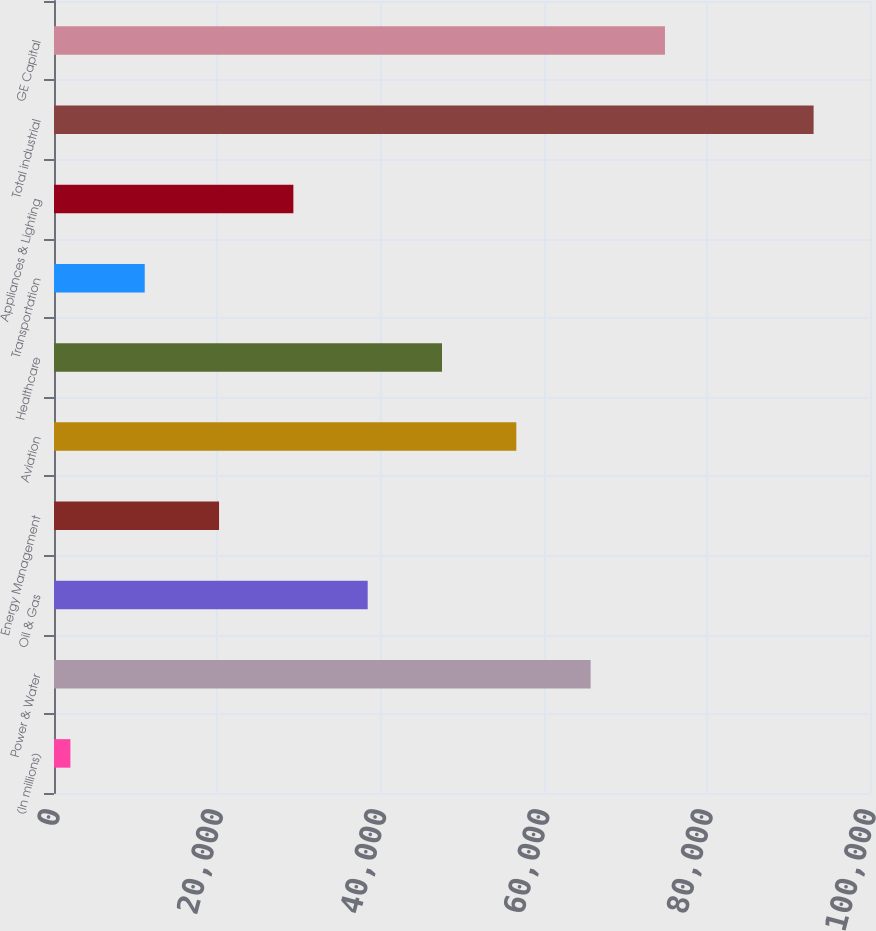<chart> <loc_0><loc_0><loc_500><loc_500><bar_chart><fcel>(In millions)<fcel>Power & Water<fcel>Oil & Gas<fcel>Energy Management<fcel>Aviation<fcel>Healthcare<fcel>Transportation<fcel>Appliances & Lighting<fcel>Total industrial<fcel>GE Capital<nl><fcel>2011<fcel>65764.9<fcel>38441.8<fcel>20226.4<fcel>56657.2<fcel>47549.5<fcel>11118.7<fcel>29334.1<fcel>93088<fcel>74872.6<nl></chart> 